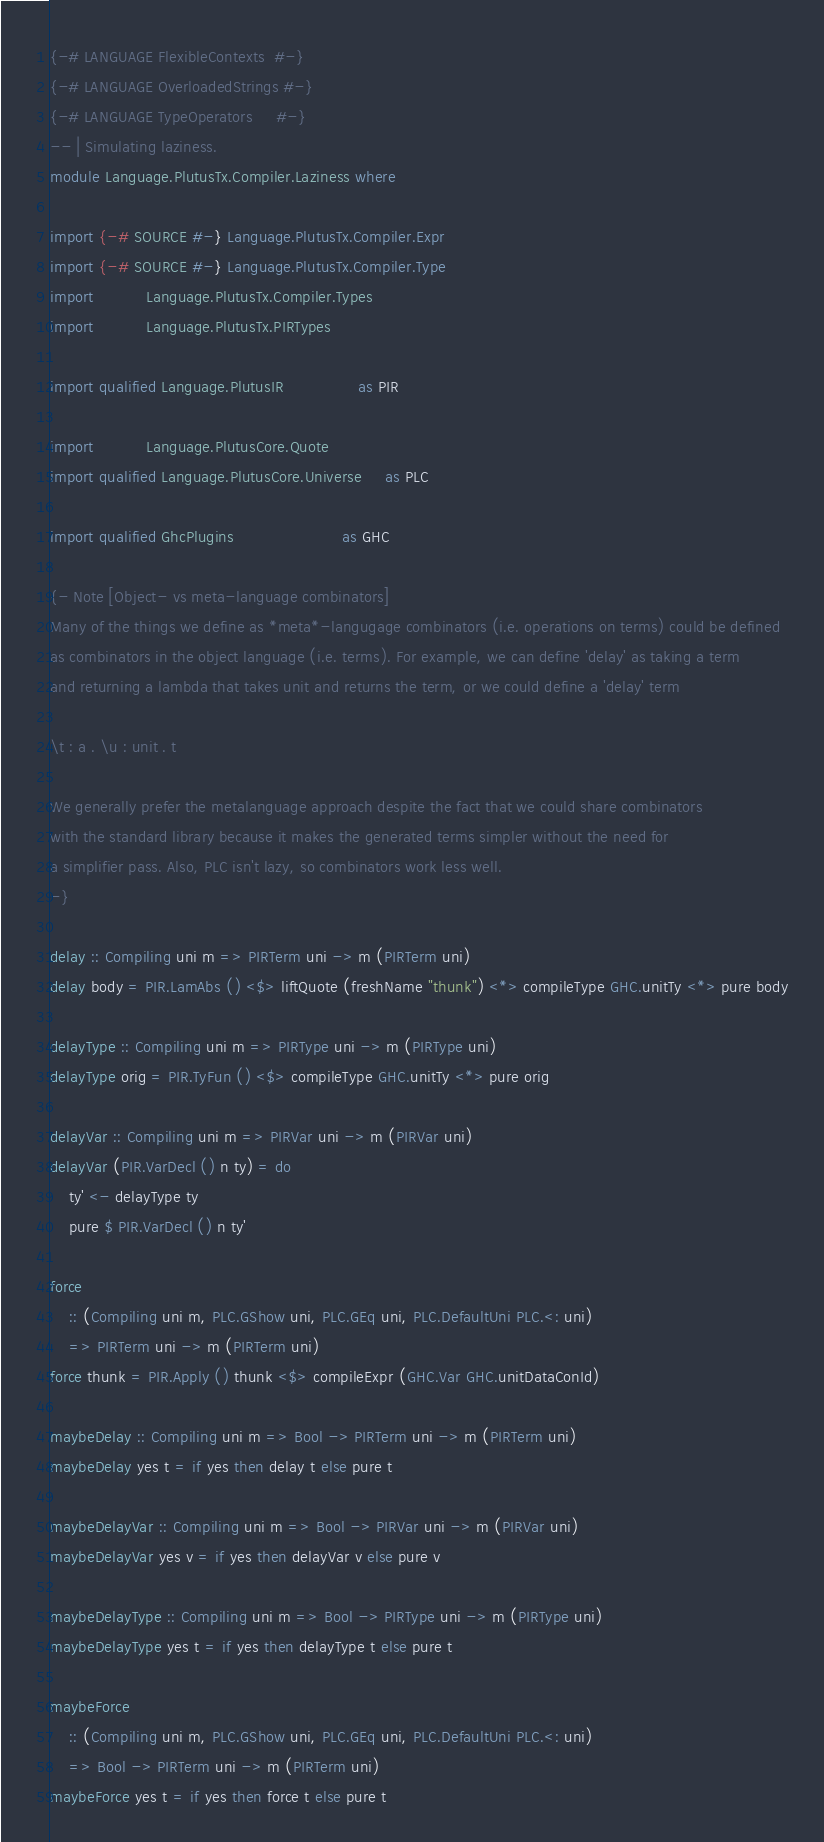<code> <loc_0><loc_0><loc_500><loc_500><_Haskell_>{-# LANGUAGE FlexibleContexts  #-}
{-# LANGUAGE OverloadedStrings #-}
{-# LANGUAGE TypeOperators     #-}
-- | Simulating laziness.
module Language.PlutusTx.Compiler.Laziness where

import {-# SOURCE #-} Language.PlutusTx.Compiler.Expr
import {-# SOURCE #-} Language.PlutusTx.Compiler.Type
import           Language.PlutusTx.Compiler.Types
import           Language.PlutusTx.PIRTypes

import qualified Language.PlutusIR                as PIR

import           Language.PlutusCore.Quote
import qualified Language.PlutusCore.Universe     as PLC

import qualified GhcPlugins                       as GHC

{- Note [Object- vs meta-language combinators]
Many of the things we define as *meta*-langugage combinators (i.e. operations on terms) could be defined
as combinators in the object language (i.e. terms). For example, we can define 'delay' as taking a term
and returning a lambda that takes unit and returns the term, or we could define a 'delay' term

\t : a . \u : unit . t

We generally prefer the metalanguage approach despite the fact that we could share combinators
with the standard library because it makes the generated terms simpler without the need for
a simplifier pass. Also, PLC isn't lazy, so combinators work less well.
-}

delay :: Compiling uni m => PIRTerm uni -> m (PIRTerm uni)
delay body = PIR.LamAbs () <$> liftQuote (freshName "thunk") <*> compileType GHC.unitTy <*> pure body

delayType :: Compiling uni m => PIRType uni -> m (PIRType uni)
delayType orig = PIR.TyFun () <$> compileType GHC.unitTy <*> pure orig

delayVar :: Compiling uni m => PIRVar uni -> m (PIRVar uni)
delayVar (PIR.VarDecl () n ty) = do
    ty' <- delayType ty
    pure $ PIR.VarDecl () n ty'

force
    :: (Compiling uni m, PLC.GShow uni, PLC.GEq uni, PLC.DefaultUni PLC.<: uni)
    => PIRTerm uni -> m (PIRTerm uni)
force thunk = PIR.Apply () thunk <$> compileExpr (GHC.Var GHC.unitDataConId)

maybeDelay :: Compiling uni m => Bool -> PIRTerm uni -> m (PIRTerm uni)
maybeDelay yes t = if yes then delay t else pure t

maybeDelayVar :: Compiling uni m => Bool -> PIRVar uni -> m (PIRVar uni)
maybeDelayVar yes v = if yes then delayVar v else pure v

maybeDelayType :: Compiling uni m => Bool -> PIRType uni -> m (PIRType uni)
maybeDelayType yes t = if yes then delayType t else pure t

maybeForce
    :: (Compiling uni m, PLC.GShow uni, PLC.GEq uni, PLC.DefaultUni PLC.<: uni)
    => Bool -> PIRTerm uni -> m (PIRTerm uni)
maybeForce yes t = if yes then force t else pure t
</code> 